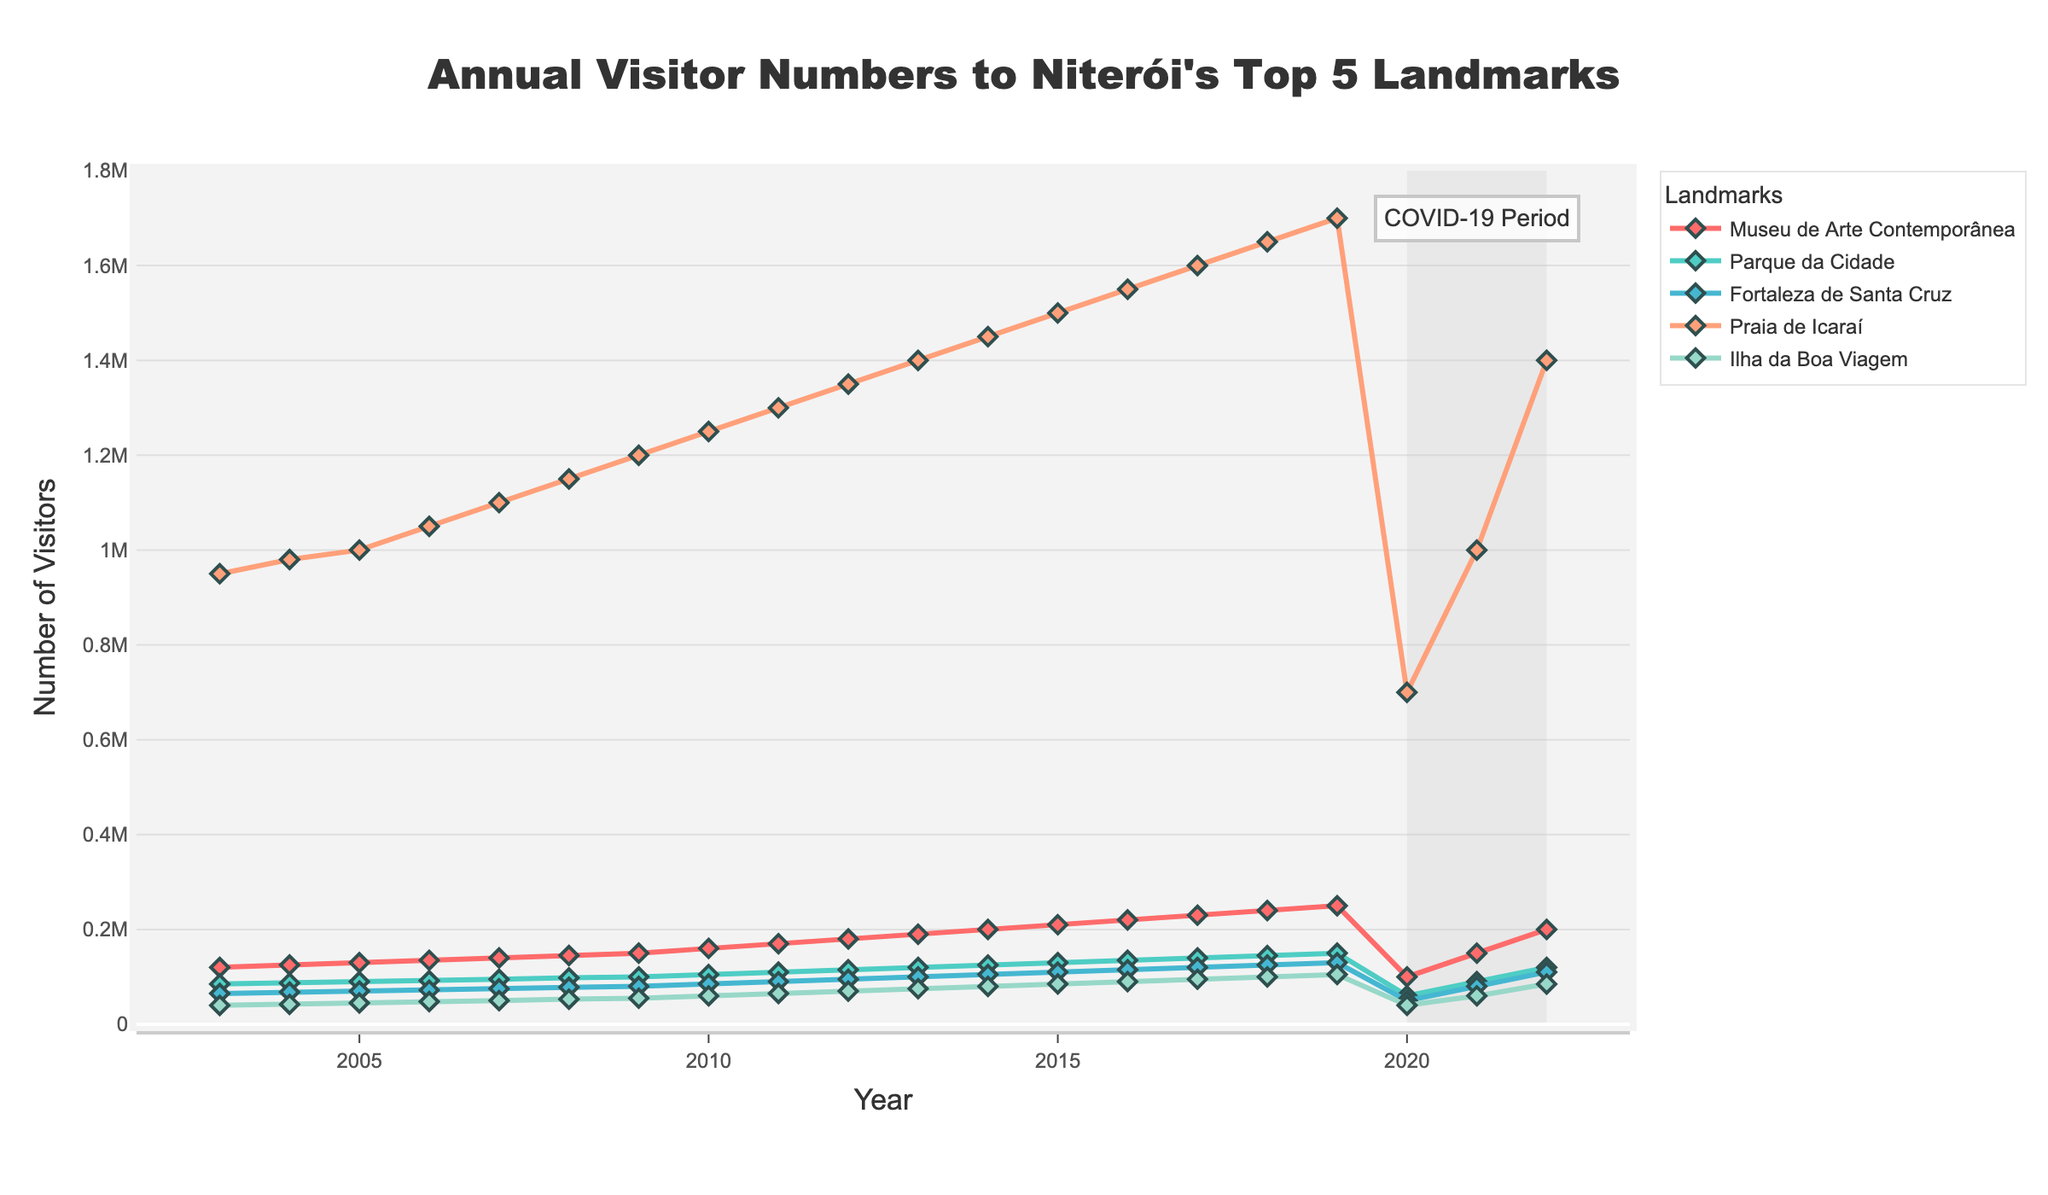Which landmark experienced the highest visitor numbers in 2019? To find the landmark with the highest visitor numbers in 2019, locate the year 2019 on the x-axis and identify the highest data point for that specific year. "Praia de Icaraí" shows the highest value in 2019.
Answer: Praia de Icaraí Between 2007 and 2009, what is the average number of visitors for Museu de Arte Contemporânea? Look at the visitor numbers for Museu de Arte Contemporânea in 2007, 2008, and 2009, which are 140,000, 145,000, and 150,000 respectively. Sum these values and divide by 3. (140,000 + 145,000 + 150,000) / 3 = 145,000.
Answer: 145,000 How did visitor numbers to all landmarks change during the COVID-19 period (2020-2022)? Assess the visitor numbers for each landmark in the years 2020, 2021, and 2022. All landmarks experienced a significant drop in 2020 and began recovering in 2021 and 2022, although not reaching pre-pandemic levels immediately.
Answer: Significant drop in 2020, partial recovery in 2021 and 2022 Which landmark had the least impact from COVID-19 in terms of visitor recovery by 2022? Compare the visitor numbers in 2022 for all landmarks to their peaks before COVID-19. The Museu de Arte Contemporânea, which reached 200,000 visitors in 2022, seems to have recovered to its 2019 levels the most.
Answer: Museu de Arte Contemporânea What was the visitor trend for Fortaleza de Santa Cruz between 2003 and 2022? Observe the line representing Fortaleza de Santa Cruz from 2003 to 2022. It shows a gradual increase from 65,000 in 2003 to its peak in 2019 at 130,000, followed by a significant drop in 2020, and a recovery trend starting in 2021.
Answer: Gradual increase, sharp decline in 2020, partial recovery Which landmark had the smallest increase in visitors over the 20 years? Calculate the difference in visitor numbers from 2003 to 2022 for each landmark. Ilha da Boa Viagem increased from 40,000 in 2003 to 85,000 in 2022. This constitutes the smallest increase of 45,000.
Answer: Ilha da Boa Viagem How does the visitor count at Parque da Cidade in 2021 compare to that in 2018? Look at the visitor numbers for Parque da Cidade in 2021 and 2018. In 2021, it was 90,000, and in 2018, it was 145,000. Comparing these shows a decrease of 55,000.
Answer: Decrease of 55,000 What was the difference in visitor numbers to Praia de Icaraí between 2016 and 2022? Count the visitors to Praia de Icaraí in 2016 (1,550,000) and in 2022 (1,400,000). Subtract the latter from the former: 1,550,000 - 1,400,000 = 150,000.
Answer: 150,000 Which landmark showed the most consistent growth in visitor numbers from 2003 to 2019? Follow the trendlines from 2003 to 2019. The Museu de Arte Contemporânea displayed linear and consistently increasing visitor numbers.
Answer: Museu de Arte Contemporânea 